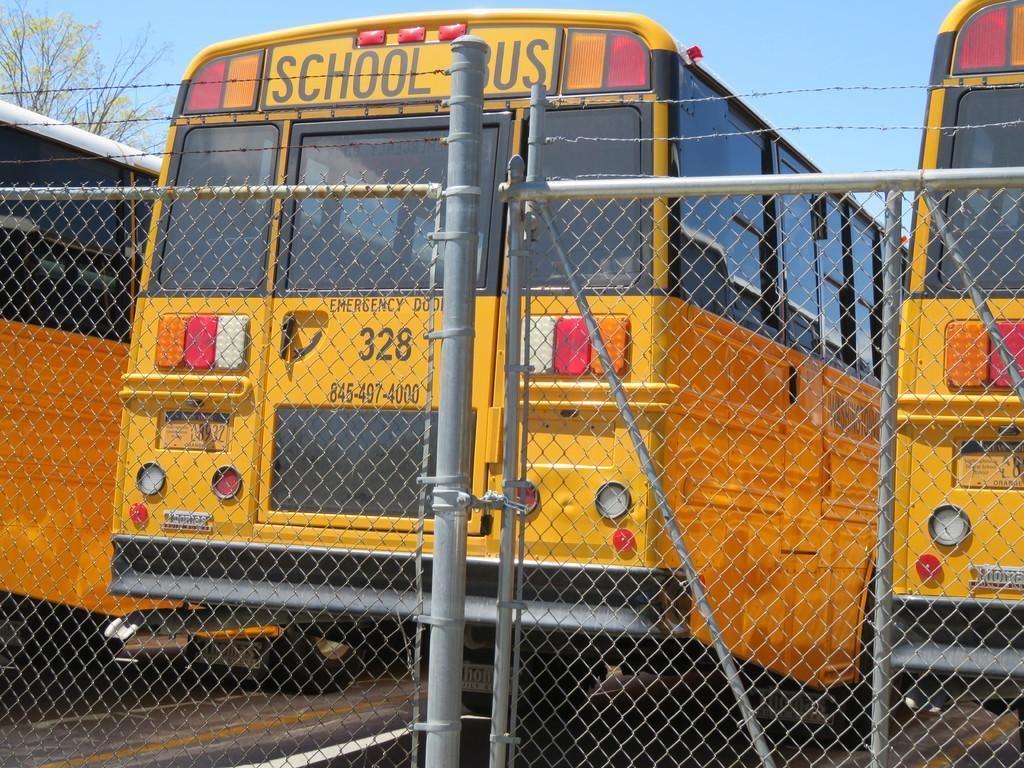In one or two sentences, can you explain what this image depicts? In the image I can see three buses which are in yellow color and also I can see a fencing behind the buses. 